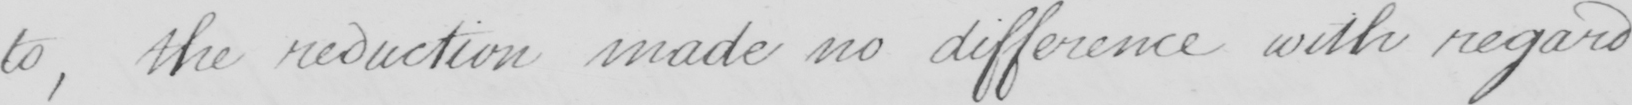What is written in this line of handwriting? to , the reduction made no difference with regard 